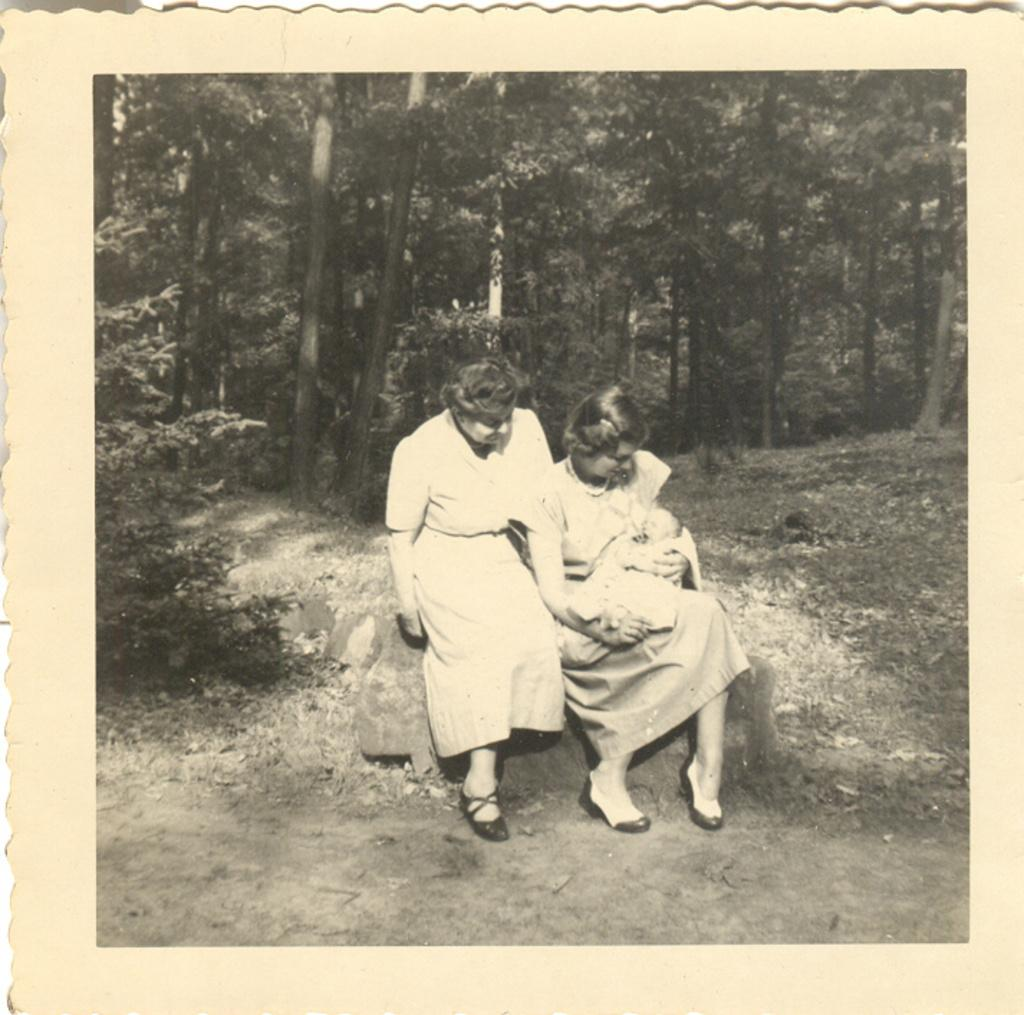What is the main subject of the photo in the image? The main subject of the photo is a picture. How many people are in the picture? The picture contains two persons. What are the persons wearing? The persons are wearing clothes. Where are the persons sitting in the picture? The persons are sitting on a rock. What can be seen in the background of the picture? There are trees in the background of the picture. What type of thrill can be seen on the faces of the babies in the image? There are no babies present in the image; it features two persons sitting on a rock. 